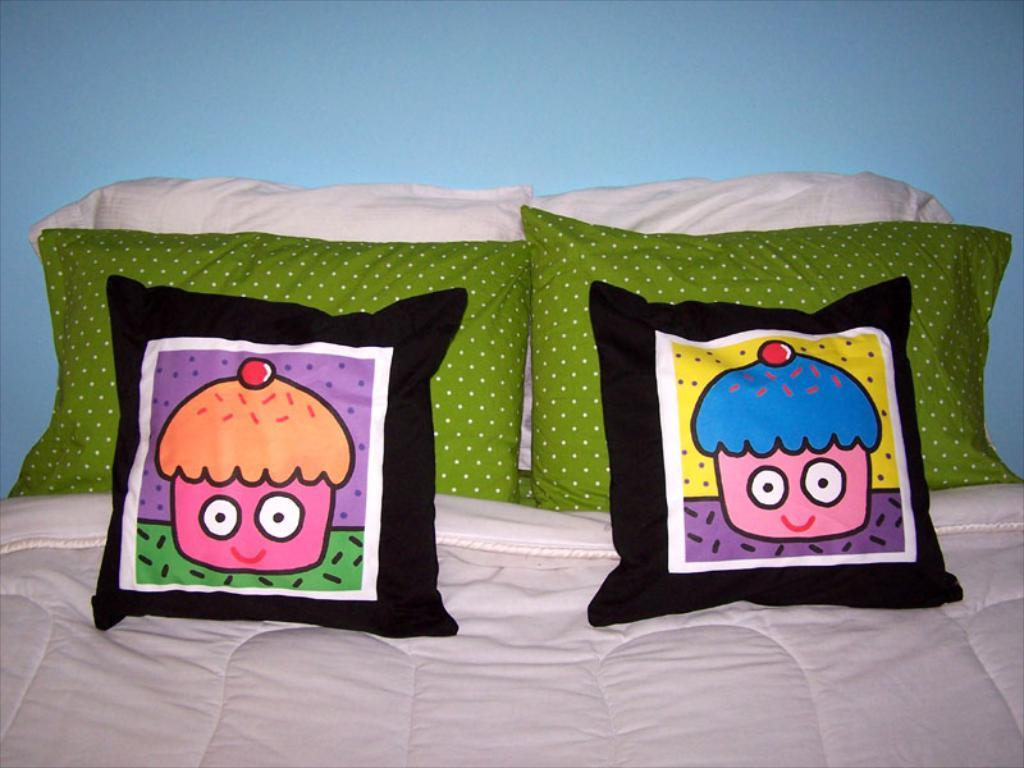What objects are on the bed in the image? There are pillows on the bed in the image. What color is the background of the image? The background of the image appears to be blue. What type of cheese is being prescribed by the doctor in the image? There is no doctor or cheese present in the image. How many stamps are visible on the pillows in the image? There are no stamps visible on the pillows in the image. 